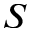<formula> <loc_0><loc_0><loc_500><loc_500>S</formula> 